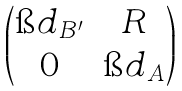<formula> <loc_0><loc_0><loc_500><loc_500>\begin{pmatrix} \i d _ { B ^ { \prime } } & R \\ 0 & \i d _ { A } \end{pmatrix}</formula> 